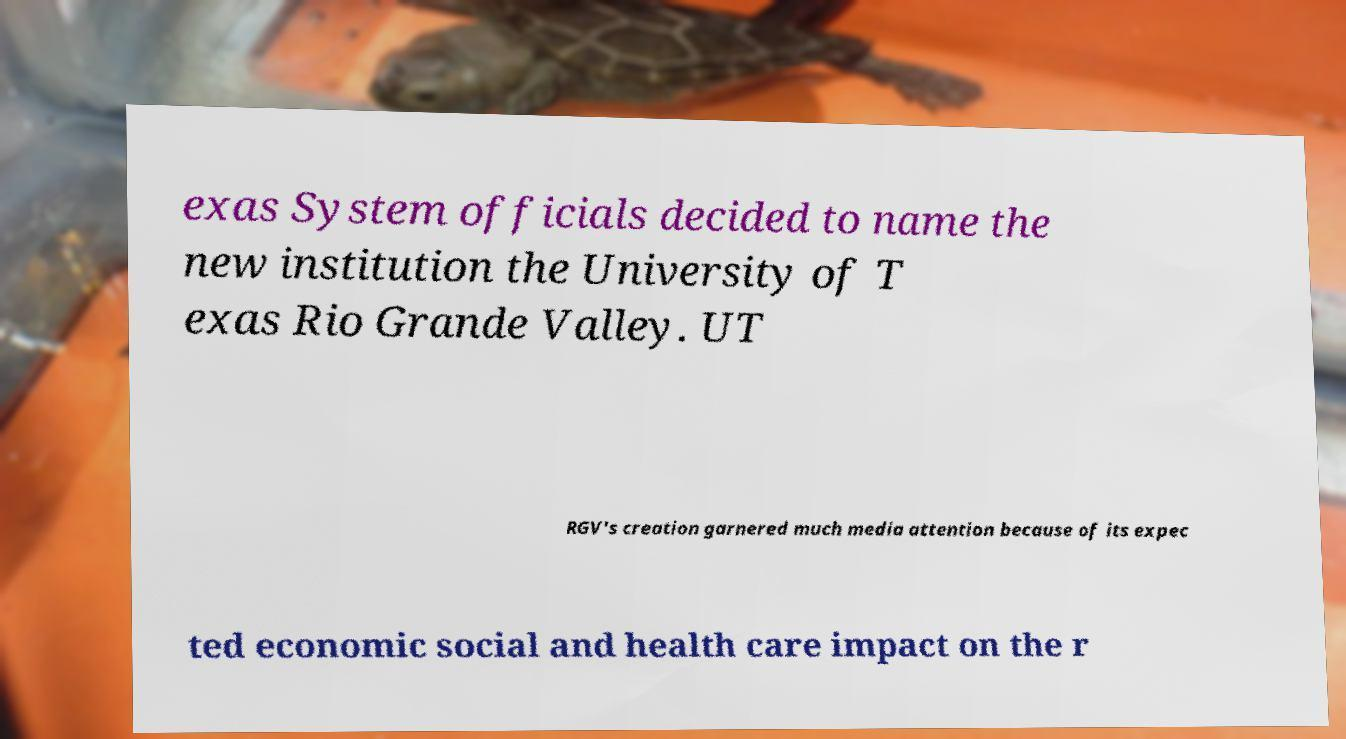Please identify and transcribe the text found in this image. exas System officials decided to name the new institution the University of T exas Rio Grande Valley. UT RGV's creation garnered much media attention because of its expec ted economic social and health care impact on the r 